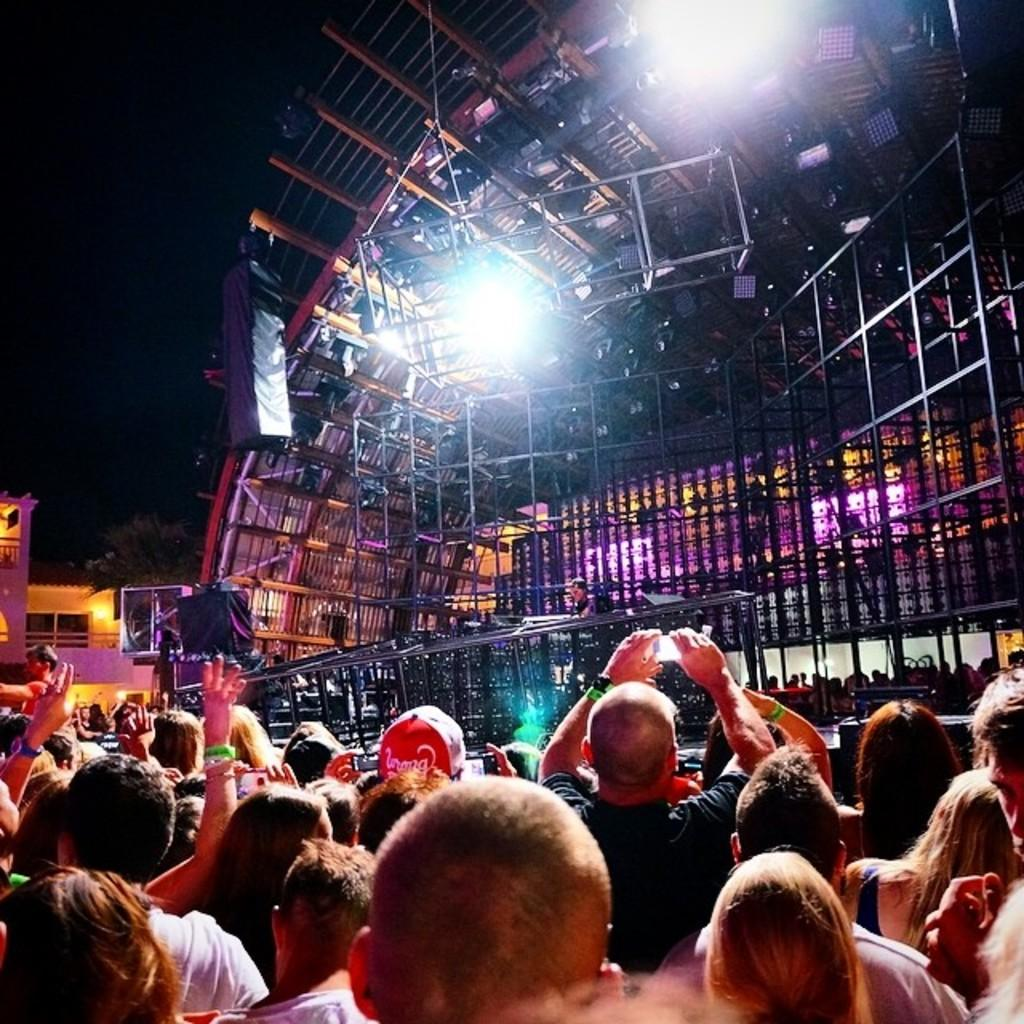What can be seen in the foreground of the image? There are people standing in the front of the image. What is located in the background of the image? There is a stage and poles in the background of the image. What is visible at the top of the image? There are lights visible at the top of the image. What type of coal is being used to fuel the stage in the image? There is no coal present in the image, and the stage is not being fueled by coal. How does the body of the person in the image react to the kick? There is no kick or any indication of physical contact in the image. 